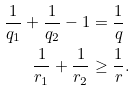Convert formula to latex. <formula><loc_0><loc_0><loc_500><loc_500>\frac { 1 } { q _ { 1 } } + \frac { 1 } { q _ { 2 } } - 1 & = \frac { 1 } { q } \\ \frac { 1 } { r _ { 1 } } + \frac { 1 } { r _ { 2 } } & \geq \frac { 1 } { r } .</formula> 